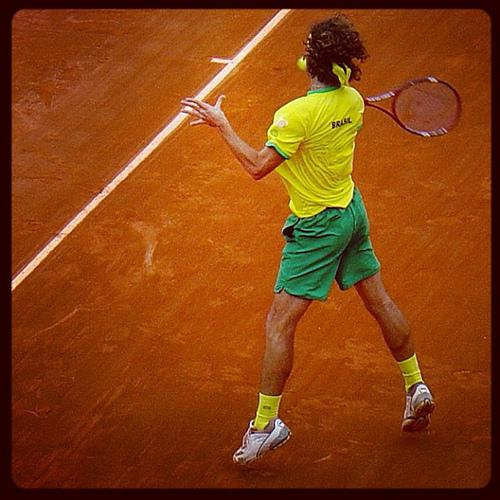Question: where is this man playing tennis?
Choices:
A. In the gym.
B. On the court.
C. At the stadium.
D. In the field.
Answer with the letter. Answer: B Question: what color is the guys shirt and socks?
Choices:
A. Yellow.
B. Blue.
C. Red.
D. Purple.
Answer with the letter. Answer: A Question: who is swinging at the ball?
Choices:
A. Baseball player.
B. Tennis player.
C. Softball player.
D. Handball player.
Answer with the letter. Answer: B Question: why are the players feet off the ground?
Choices:
A. Jumping to make a basket.
B. Blocking a shot.
C. Catching a frisbee.
D. Hitting the ball.
Answer with the letter. Answer: D Question: what color are the shorts?
Choices:
A. Blue.
B. Red.
C. Black.
D. Green.
Answer with the letter. Answer: D Question: what does the back of the shirt say?
Choices:
A. Brazil.
B. Columbia.
C. Usa.
D. Mexico.
Answer with the letter. Answer: A 